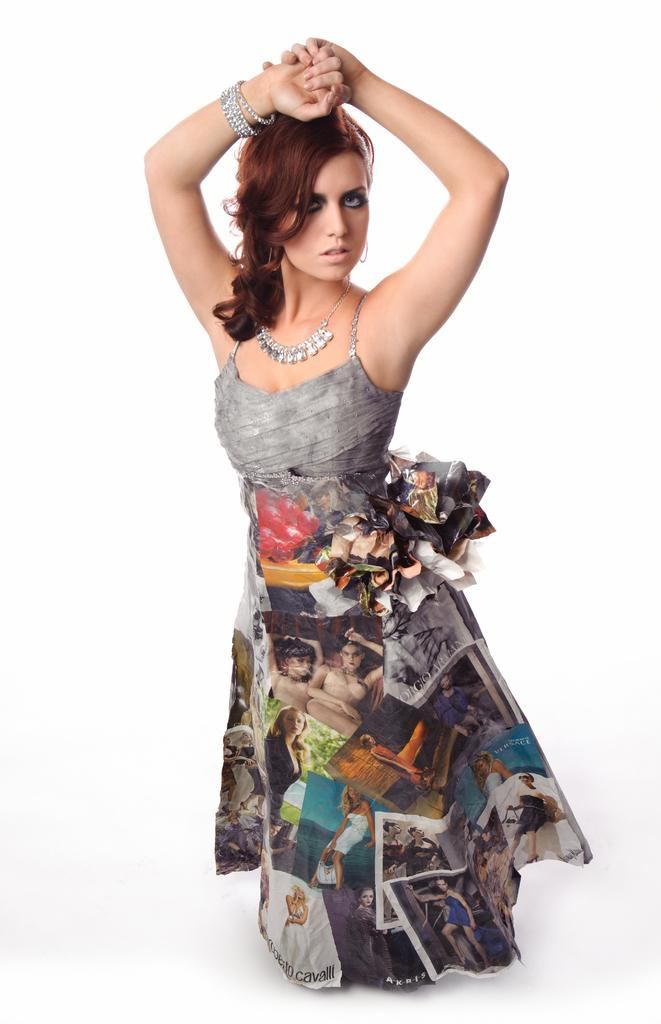Who is present in the image? There is a woman in the image. What is the woman doing in the image? The woman is standing. What caption is written below the woman in the image? There is no caption present in the image. What type of can is visible in the image? There is no can present in the image. 